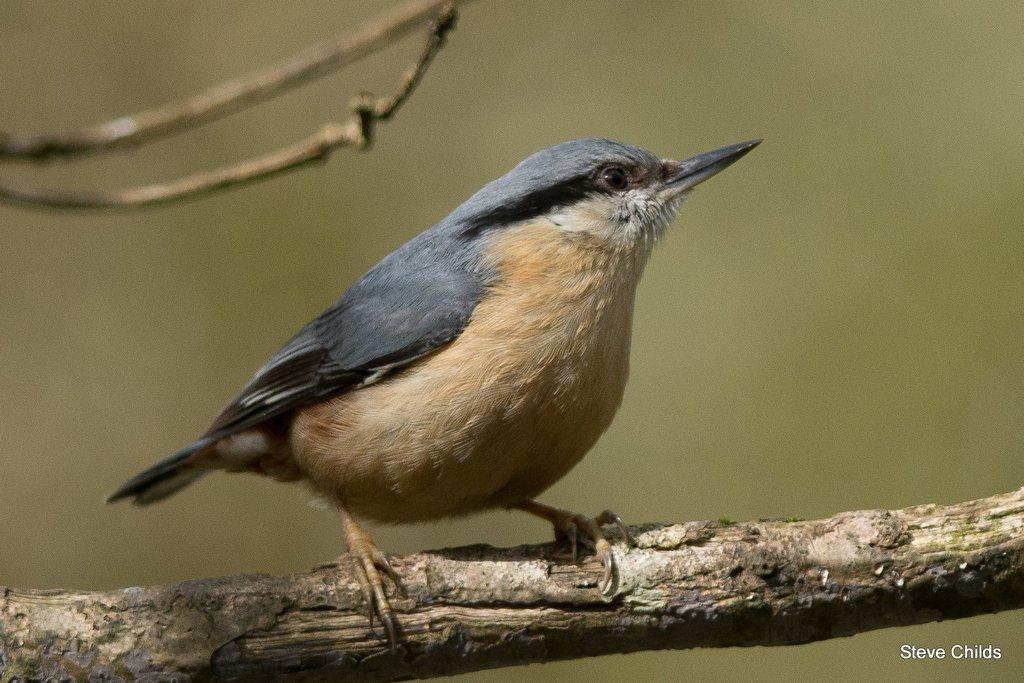How would you summarize this image in a sentence or two? There is a bird on a stem. In the right bottom corner there is a watermark. 